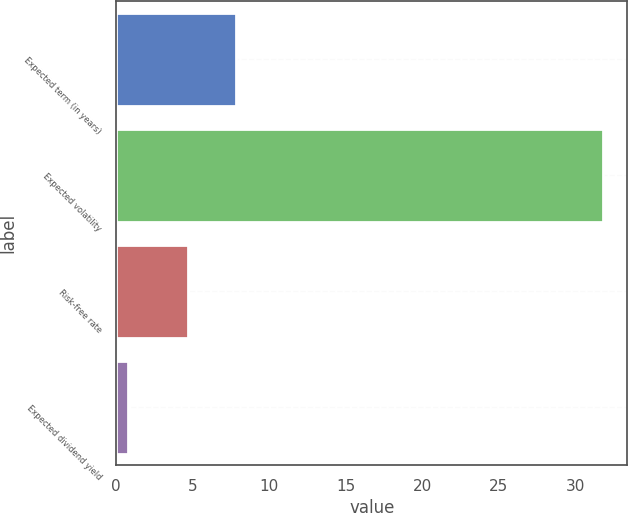Convert chart to OTSL. <chart><loc_0><loc_0><loc_500><loc_500><bar_chart><fcel>Expected term (in years)<fcel>Expected volatility<fcel>Risk-free rate<fcel>Expected dividend yield<nl><fcel>7.8<fcel>31.8<fcel>4.7<fcel>0.8<nl></chart> 